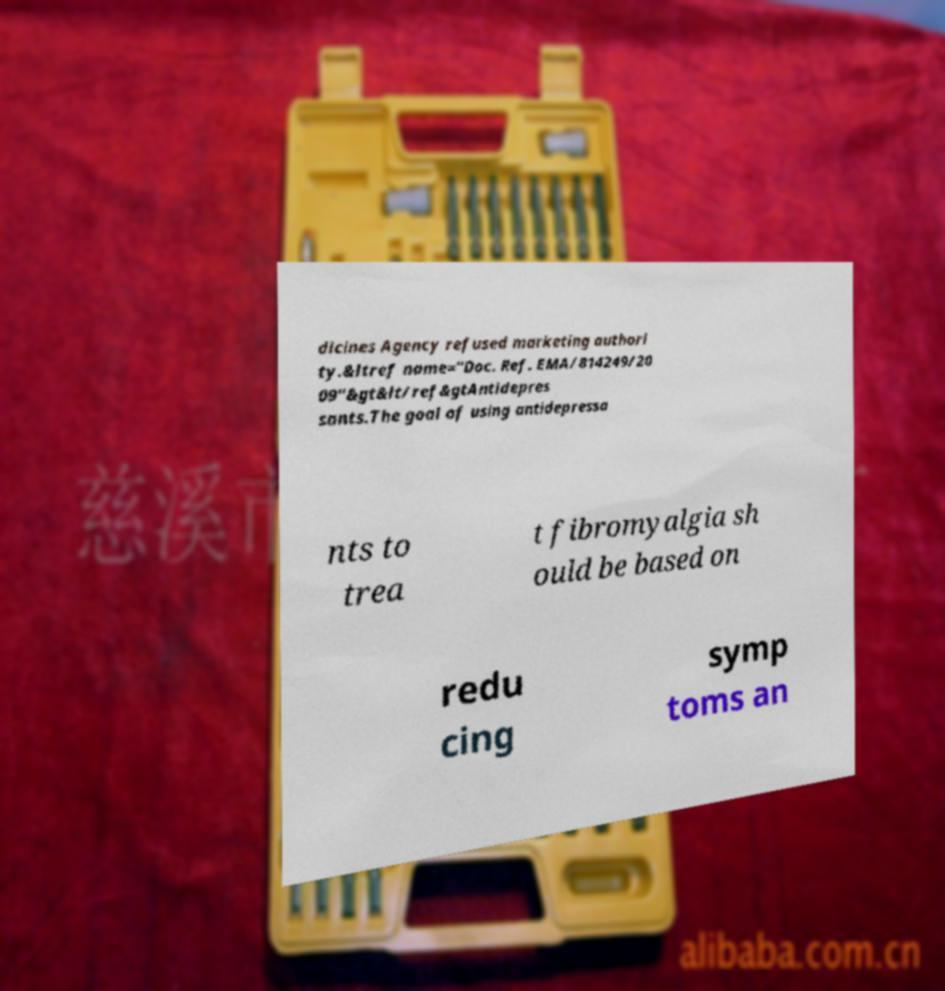I need the written content from this picture converted into text. Can you do that? dicines Agency refused marketing authori ty.&ltref name="Doc. Ref. EMA/814249/20 09"&gt&lt/ref&gtAntidepres sants.The goal of using antidepressa nts to trea t fibromyalgia sh ould be based on redu cing symp toms an 